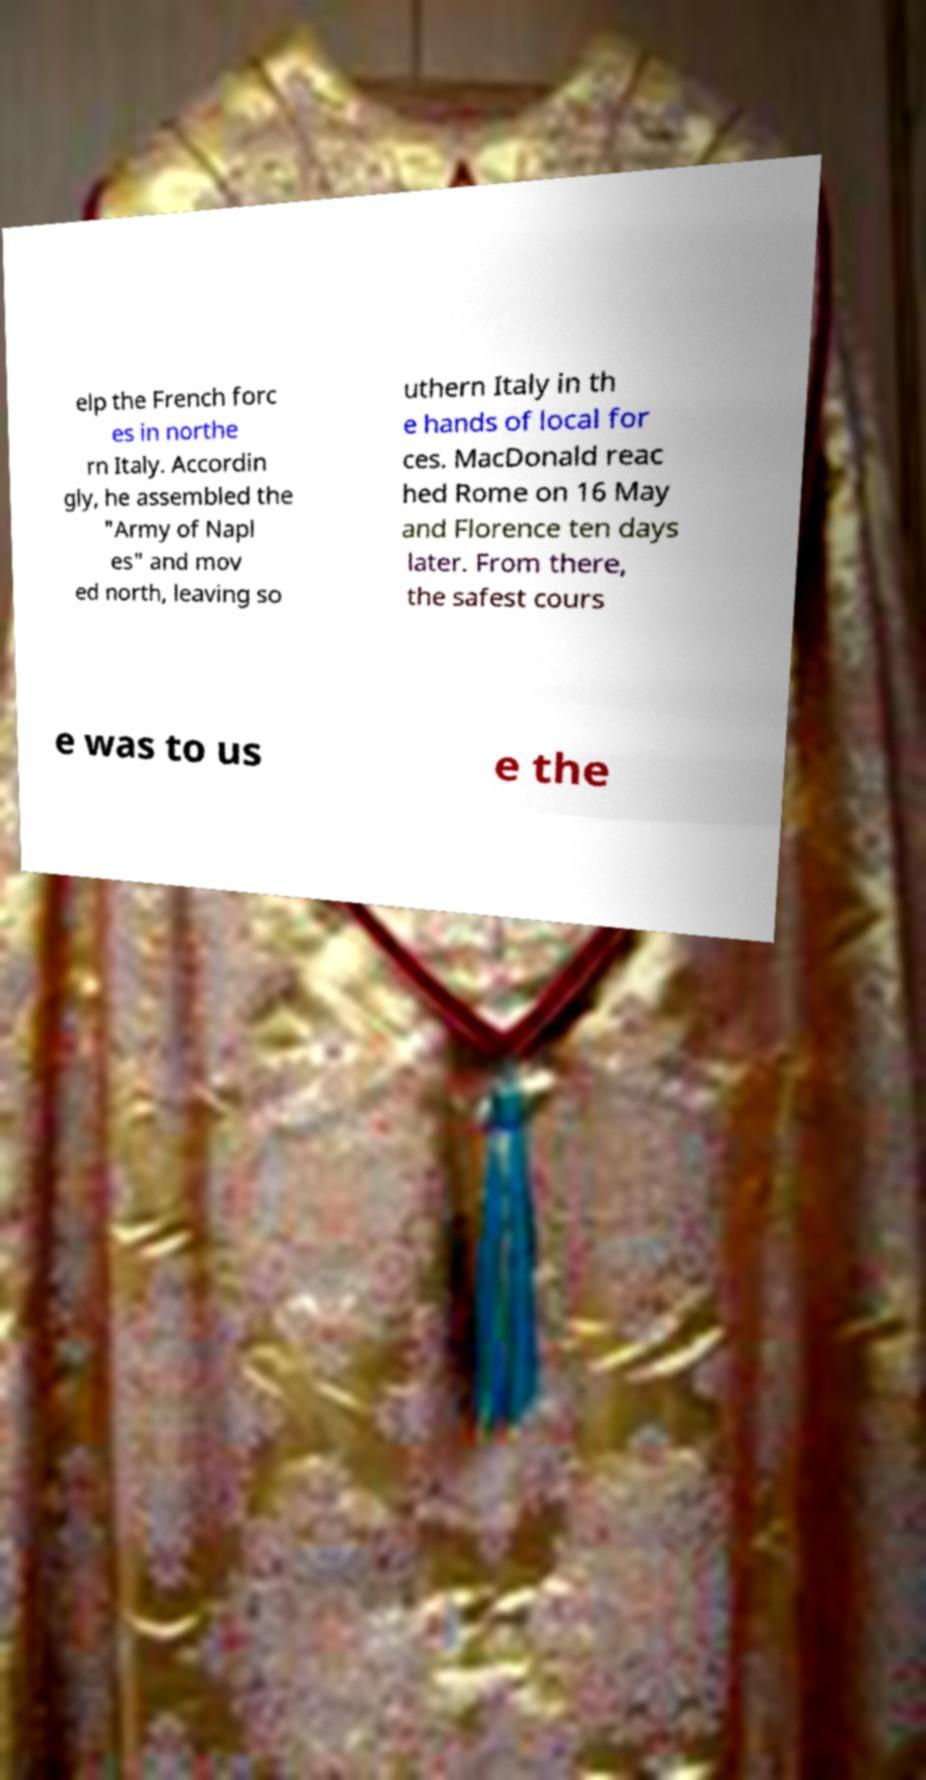Can you accurately transcribe the text from the provided image for me? elp the French forc es in northe rn Italy. Accordin gly, he assembled the "Army of Napl es" and mov ed north, leaving so uthern Italy in th e hands of local for ces. MacDonald reac hed Rome on 16 May and Florence ten days later. From there, the safest cours e was to us e the 